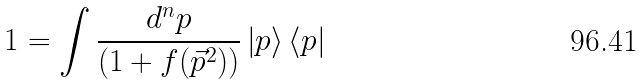Convert formula to latex. <formula><loc_0><loc_0><loc_500><loc_500>1 = \int \frac { d ^ { n } p } { \left ( 1 + f ( \vec { p } ^ { 2 } ) \right ) } \left | p \right > \left < p \right |</formula> 